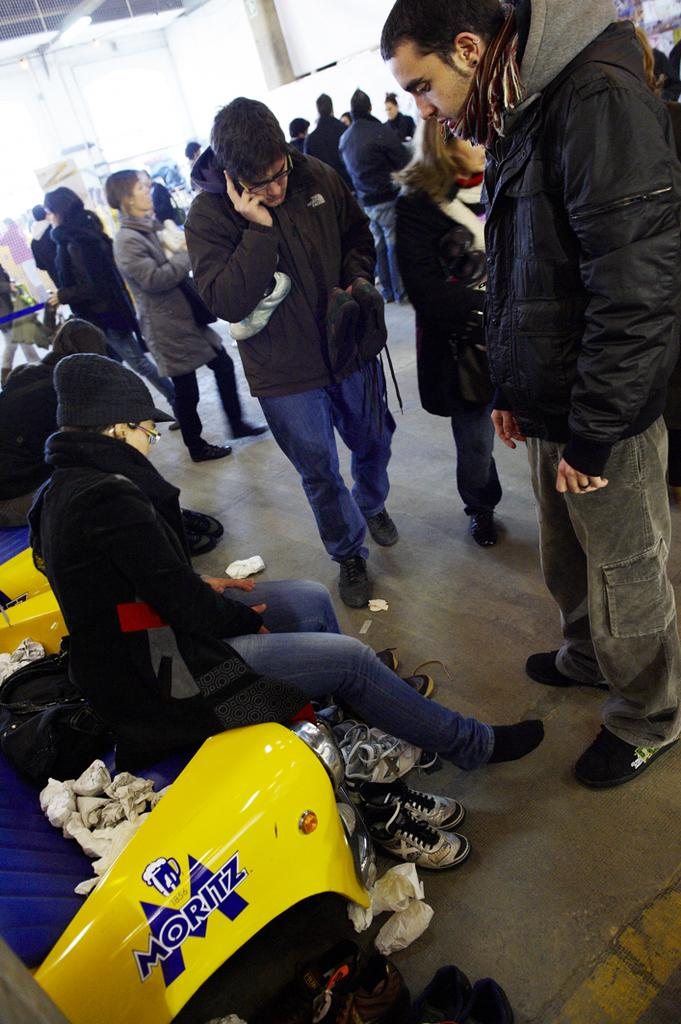Who or what is present in the image? There are people in the image. What is the color of the wall in the image? There is a white color wall in the image. What is the source of light in the image? There is a light in the image. What type of footwear can be seen in the image? There are shoes in the image. What type of furniture is present in the image? There is a plastic sofa in the image. Can you tell me how many toads are sitting on the plastic sofa in the image? There are no toads present in the image; it features people, a white wall, a light, shoes, and a plastic sofa. 